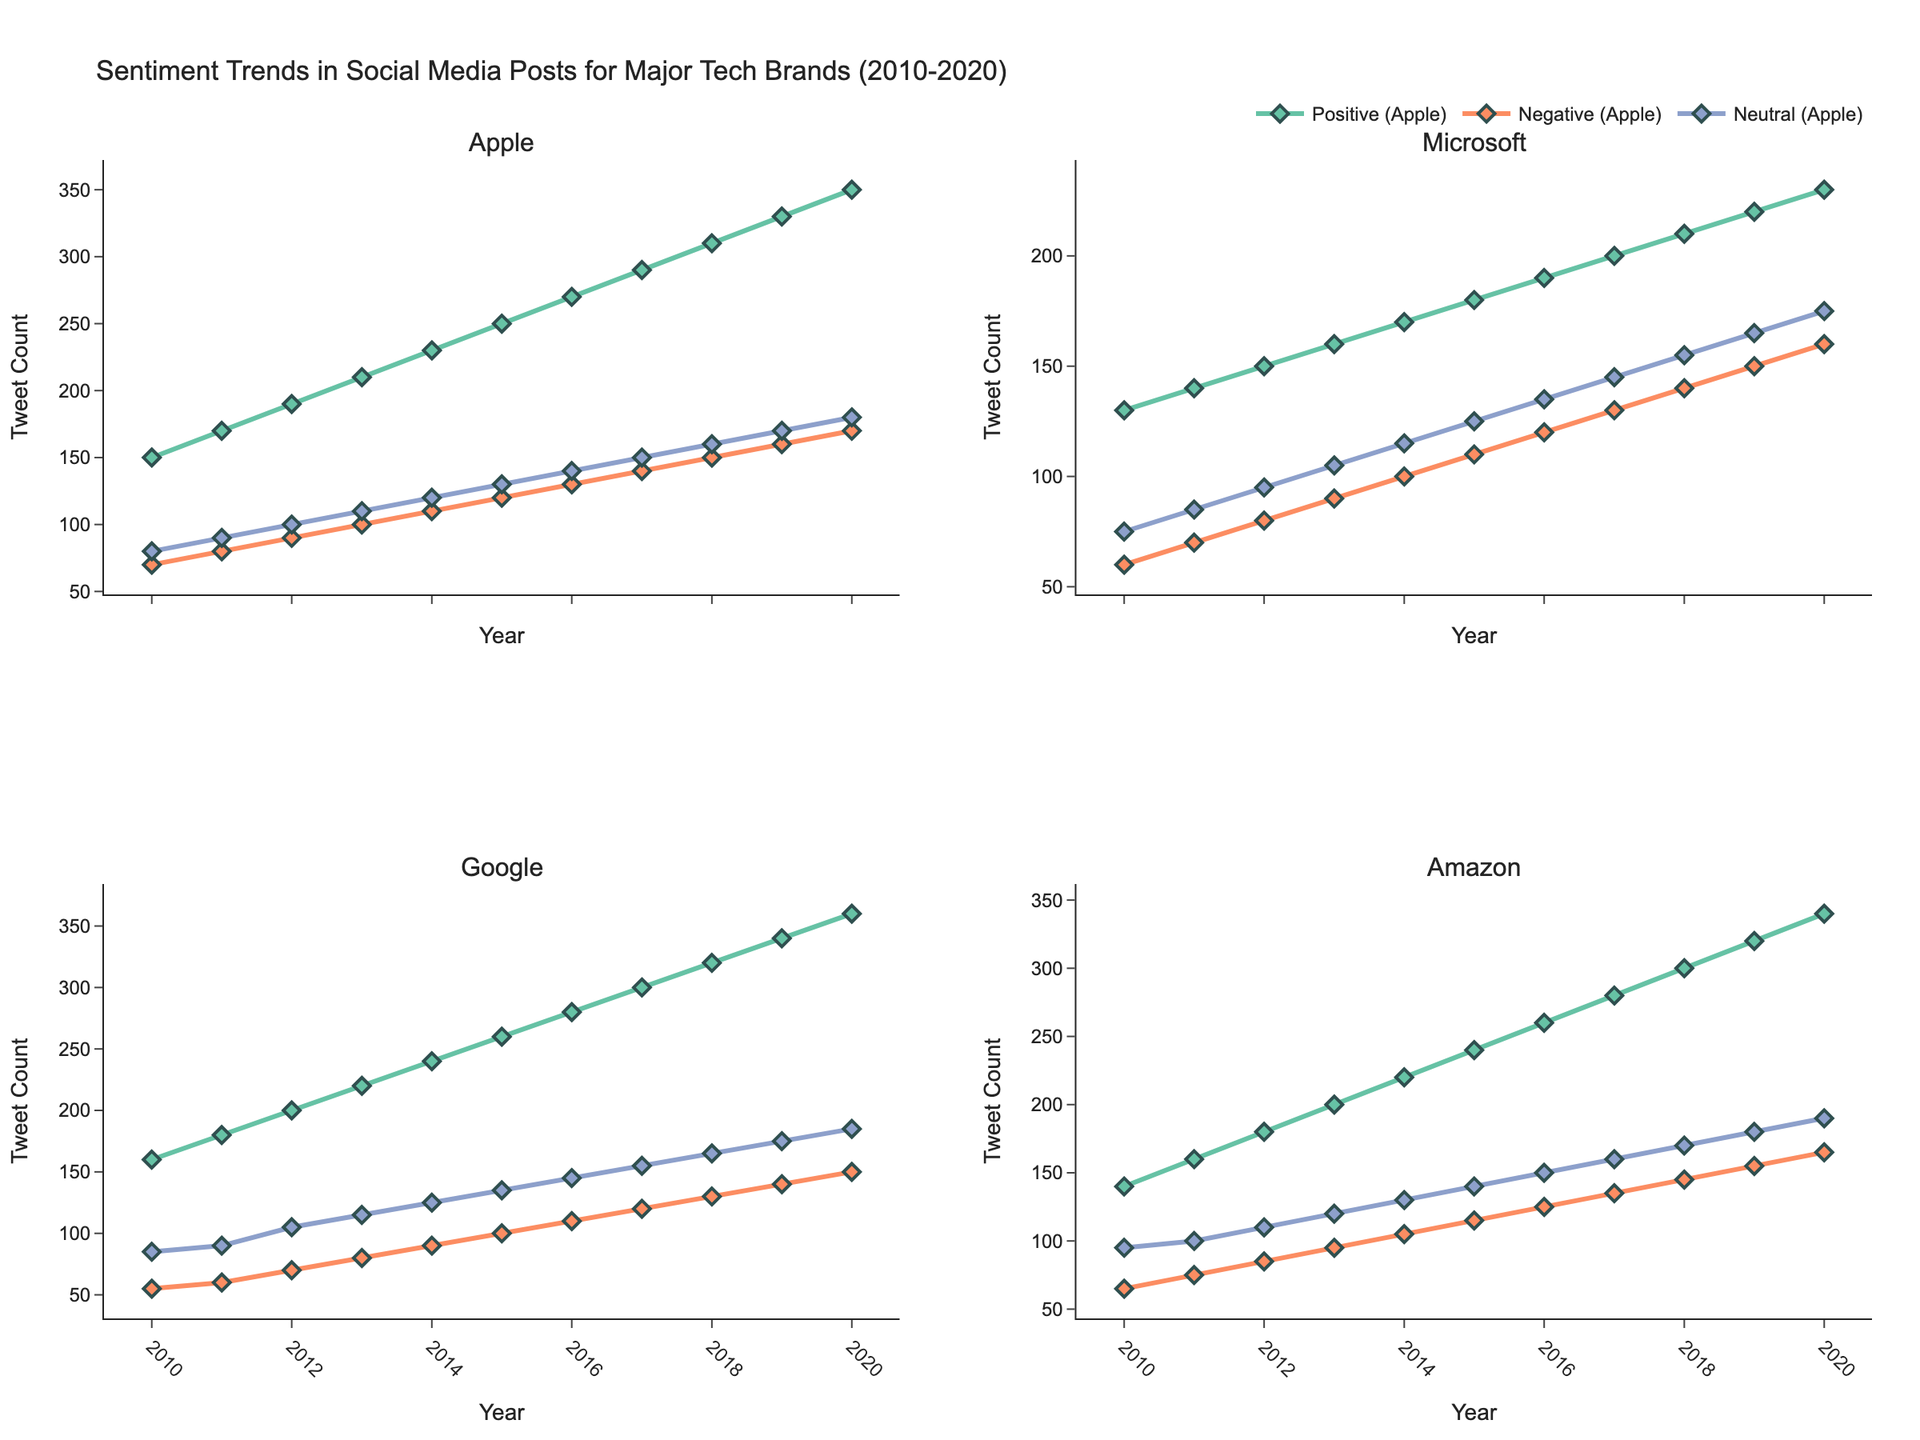Which brand has the highest positive tweet count in 2020? Look at the 2020 column for positive tweets across all brands. Apple has the highest count with 350 positive tweets.
Answer: Apple Which year did Google surpass 300 positive tweets? Check the positive tweet counts for Google over the years and identify the first year it goes above 300. In 2017, Google reached 300 positive tweets.
Answer: 2017 What are the trends in neutral tweet counts for Amazon from 2010 to 2020? Observe the neutral tweet counts for Amazon over the decade. The counts increase steadily from 95 in 2010 to 190 in 2020.
Answer: Steady increase Which brand experienced the greatest overall increase in positive tweet count from 2010 to 2020? Calculate the difference between the 2020 and 2010 positive tweet counts for each brand. Google has the greatest increase, from 160 to 360, an increase of 200.
Answer: Google How do the negative tweet counts for Microsoft and Amazon compare in 2018? Compare the negative tweet counts for Microsoft and Amazon in 2018. Microsoft has 140 and Amazon has 145 negative tweets, so Amazon has more.
Answer: Amazon What's the range of neutral tweet counts for Apple in this dataset? Identify the minimum and maximum neutral tweet counts for Apple. The minimum is 80 in 2010 and maximum is 180 in 2020. The range is 180 - 80 = 100.
Answer: 100 Which brand consistently has the highest neutral tweet count throughout the decade? Check the neutral tweet counts across each year for all brands. Amazon consistently has the highest neutral tweet counts in each year listed.
Answer: Amazon Between which years did Apple see the largest increase in positive tweet counts? Calculate year-by-year increases in positive tweets for Apple. The largest increase is between 2019 and 2020, where the count increased from 330 to 350, a difference of 20.
Answer: 2019–2020 How did the sentiment trends for Microsoft change from 2010 to 2020? Look at positive, negative, and neutral trends for Microsoft. All tweet counts (positive, negative, neutral) steadily increase over the decade, indicating growing engagement.
Answer: Steady increase What's the average number of negative tweets for Google from 2010 to 2020? Sum the negative tweet counts for Google (55, 60, 70, 80, 90, 100, 110, 120, 130, 140, 150) and divide by 11. The average is (55+60+70+80+90+100+110+120+130+140+150)/11 ≈ 100.5.
Answer: 100.5 